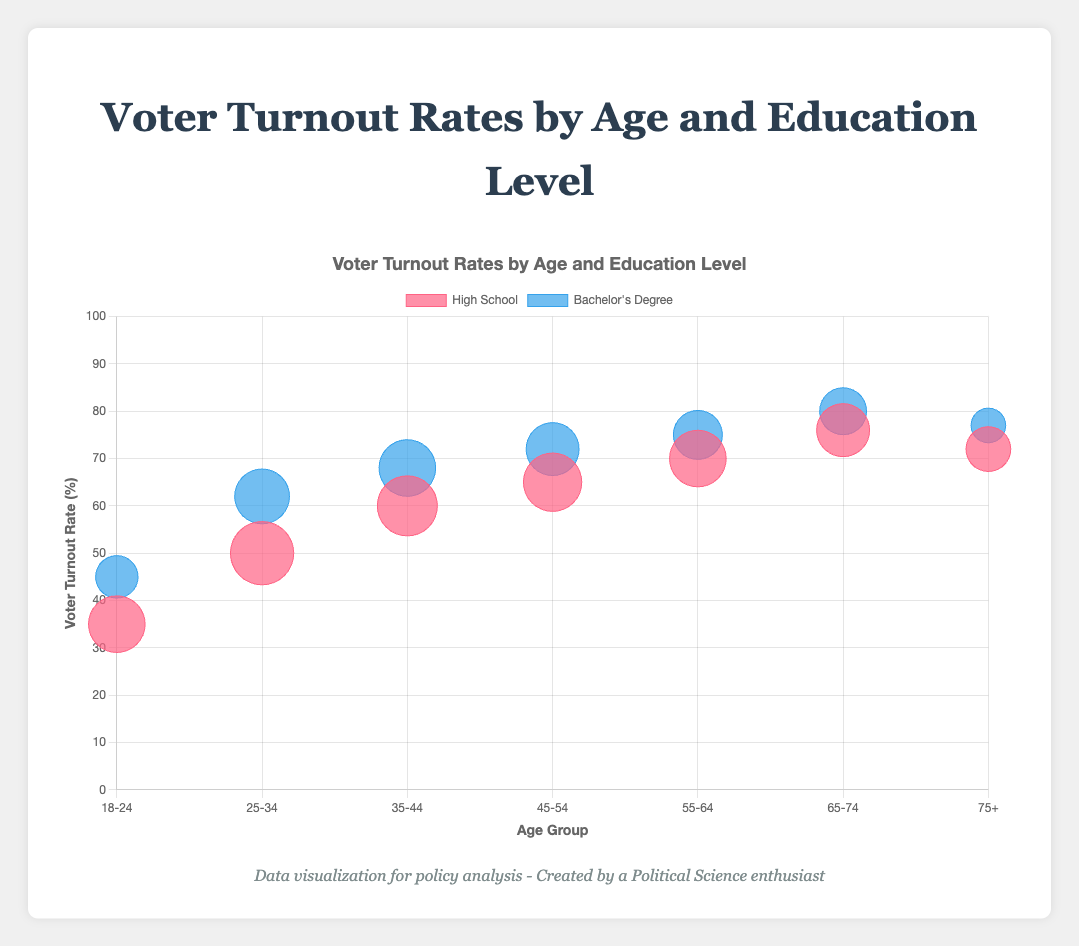How was the voter turnout rate for the 55-64 age group with a Bachelor's Degree? The bubble chart shows the y-axis representing voter turnout rates. Locate the 55-64 age group on the x-axis and look for the bubble corresponding to Bachelor's Degree education. The y-position of this bubble indicates the voter turnout rate.
Answer: 75% What is the relationship between education level and voter turnout rate for the 18-24 age group? On the x-axis, find the 18-24 age group and compare the bubbles for High School and Bachelor's Degree. Observe the vertical positions to determine voter turnout rates; bubbles higher on the y-axis indicate higher voter turnout.
Answer: Higher education correlates with higher voter turnout Which age group with a High School education has the highest voter turnout rate? Examine the vertical positions of bubbles labeled "High School" on the y-axis across different age groups. The bubble with the highest y-position is the one with the highest voter turnout rate.
Answer: 65-74 What is the difference in voter turnout rates between the lowest and highest values for Bachelor's Degree holders? For Bachelor's Degree holders, identify the highest and lowest bubbles in terms of voter turnout rate by comparing vertical positions. The highest is for the 65-74 age group at 80%, and the lowest is the 18-24 age group at 45%. Subtract the lowest from the highest (80% - 45%).
Answer: 35% How does the population size for the 25-34 age group with High School education compare to the 35-44 age group with the same education? On the x-axis, find the bubbles for the 25-34 and 35-44 age groups labeled "High School." The size of these bubbles indicates population size. The bubble with the larger radius represents a larger population.
Answer: 25-34 is larger Which education level has a higher voter turnout rate within the 55-64 age group? Locate the two bubbles for the 55-64 age group on the x-axis, one for High School and one for Bachelor's Degree. Compare their vertical positions to determine which is higher on the y-axis.
Answer: Bachelor's Degree In the context of the entire chart, does a higher education level generally correlate with higher voter turnout rates across all age groups? Analyze the vertical positions of bubbles categorized by education level across all age groups. Generally, Bachelor's Degree bubbles are higher on the y-axis compared to High School bubbles, indicating higher voter turnout rates.
Answer: Yes What is the median voter turnout rate for Bachelor's Degree holders across all age groups? Identify all voter turnout rates for Bachelor's Degree holders: 45%, 62%, 68%, 72%, 75%, 80%, 77%. Arrange them in ascending order: 45%, 62%, 68%, 72%, 75%, 77%, 80%. The median value is the middle one in this ordered list.
Answer: 72% What is the trend in voter turnout rate with increasing age for those with a High School education? Observe the vertical positions of High School bubbles from left to right across the x-axis, corresponding to increasing age. Generally, bubbles position higher on the y-axis as age increases.
Answer: Increasing Compare the voter turnout rate of the 75+ age group for High School and Bachelor's Degree holders. Locate the bubbles for the 75+ age group on the x-axis and compare the vertical positions. The bubble for Bachelor's Degree should be higher than the one for High School on the y-axis.
Answer: Bachelor's Degree is higher 